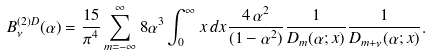<formula> <loc_0><loc_0><loc_500><loc_500>B _ { \nu } ^ { ( 2 ) D } ( \alpha ) = \frac { 1 5 } { \pi ^ { 4 } } \sum _ { m = - \infty } ^ { \infty } 8 \alpha ^ { 3 } \int _ { 0 } ^ { \infty } x \, d x \frac { 4 \, \alpha ^ { 2 } } { ( 1 - \alpha ^ { 2 } ) } \frac { 1 } { D _ { m } ( \alpha ; x ) } \frac { 1 } { D _ { m + \nu } ( \alpha ; x ) } .</formula> 